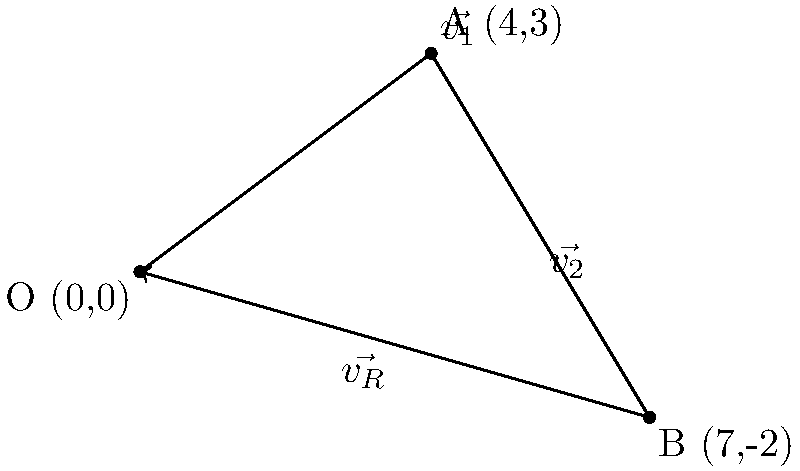A Velociraptor is running in a 2D plane. Its initial velocity vector $\vec{v_1}$ is represented by the displacement from O to A, and its final velocity vector $\vec{v_2}$ is represented by the displacement from A to B. Calculate the resultant velocity vector $\vec{v_R}$ (magnitude and direction) of the Velociraptor. To solve this problem, we'll follow these steps:

1) First, we need to find the components of $\vec{v_1}$ and $\vec{v_2}$:

   $\vec{v_1} = (4,3)$
   $\vec{v_2} = (7-4, -2-3) = (3,-5)$

2) The resultant velocity vector $\vec{v_R}$ is the sum of $\vec{v_1}$ and $\vec{v_2}$:

   $\vec{v_R} = \vec{v_1} + \vec{v_2} = (4+3, 3-5) = (7,-2)$

3) To find the magnitude of $\vec{v_R}$, we use the Pythagorean theorem:

   $|\vec{v_R}| = \sqrt{7^2 + (-2)^2} = \sqrt{53} \approx 7.28$ m/s

4) To find the direction of $\vec{v_R}$, we calculate the angle it makes with the positive x-axis:

   $\theta = \tan^{-1}(\frac{-2}{7}) \approx -15.95°$

   Note: The negative angle indicates that the vector is below the x-axis.

5) Convert the angle to degrees counterclockwise from the positive x-axis:

   $360° - 15.95° = 344.05°$

Therefore, the resultant velocity vector $\vec{v_R}$ has a magnitude of approximately 7.28 m/s and a direction of 344.05° counterclockwise from the positive x-axis.
Answer: $|\vec{v_R}| \approx 7.28$ m/s, $\theta \approx 344.05°$ 